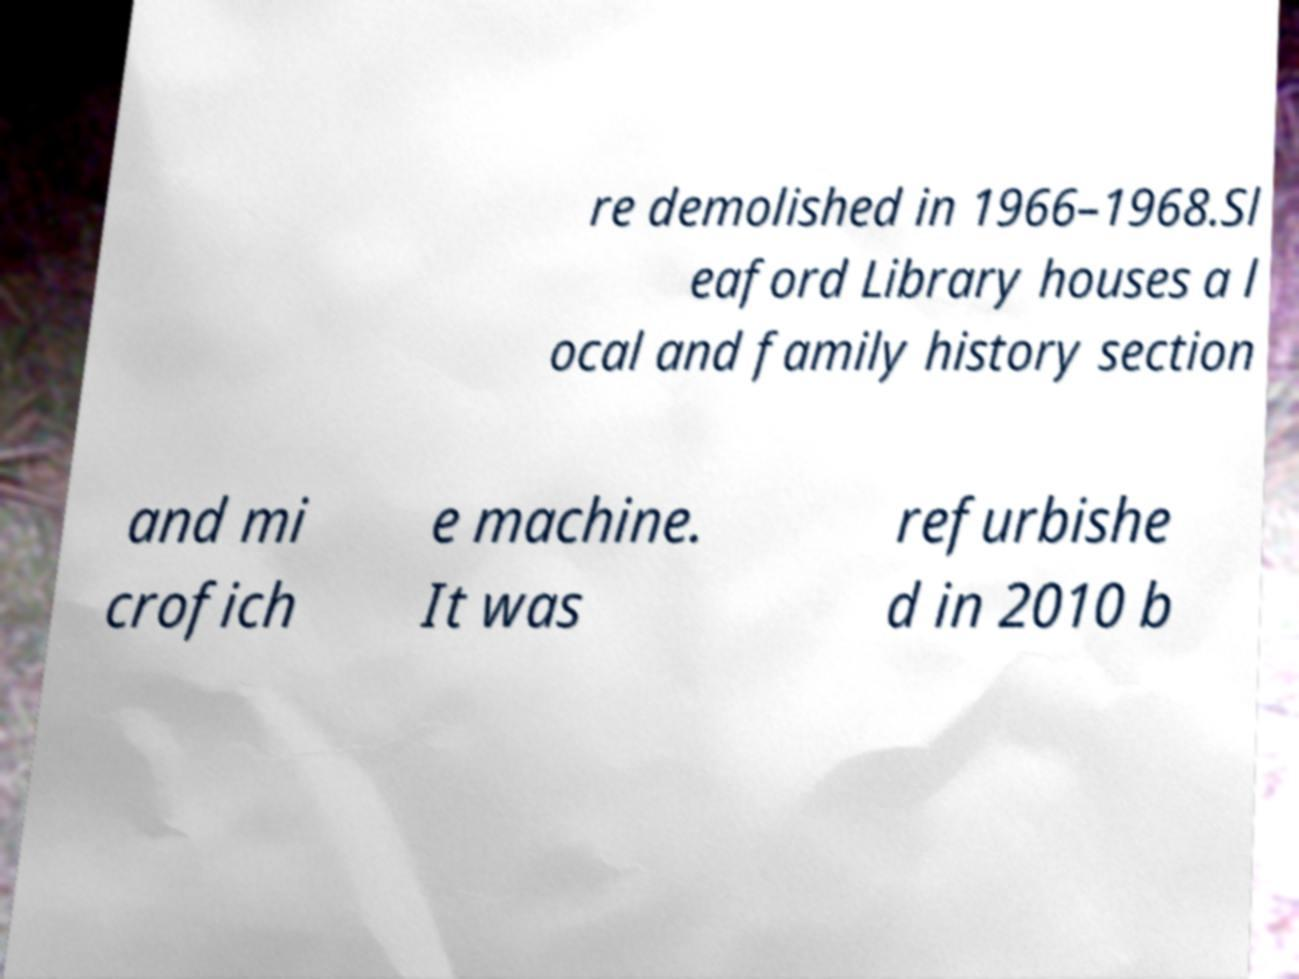Please read and relay the text visible in this image. What does it say? re demolished in 1966–1968.Sl eaford Library houses a l ocal and family history section and mi crofich e machine. It was refurbishe d in 2010 b 